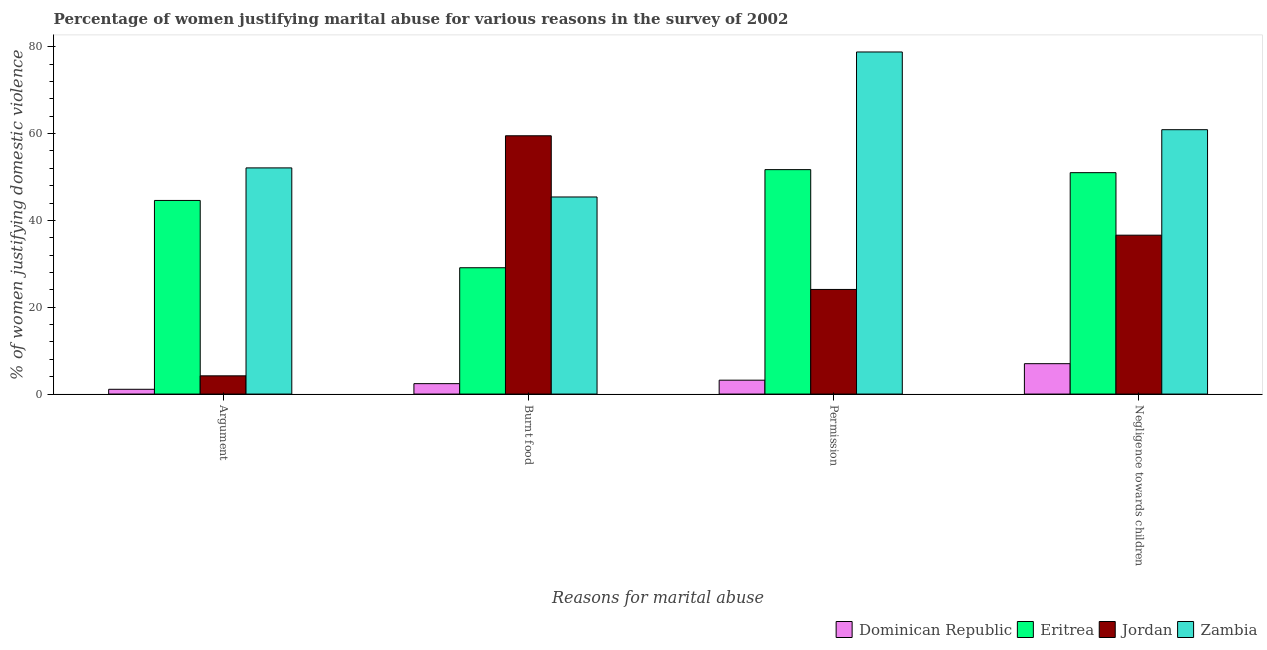Are the number of bars per tick equal to the number of legend labels?
Your response must be concise. Yes. How many bars are there on the 3rd tick from the left?
Keep it short and to the point. 4. How many bars are there on the 3rd tick from the right?
Your response must be concise. 4. What is the label of the 1st group of bars from the left?
Provide a succinct answer. Argument. What is the percentage of women justifying abuse in the case of an argument in Zambia?
Offer a terse response. 52.1. Across all countries, what is the maximum percentage of women justifying abuse for going without permission?
Ensure brevity in your answer.  78.8. In which country was the percentage of women justifying abuse for going without permission maximum?
Make the answer very short. Zambia. In which country was the percentage of women justifying abuse in the case of an argument minimum?
Ensure brevity in your answer.  Dominican Republic. What is the total percentage of women justifying abuse for going without permission in the graph?
Offer a very short reply. 157.8. What is the difference between the percentage of women justifying abuse in the case of an argument in Eritrea and that in Zambia?
Give a very brief answer. -7.5. What is the difference between the percentage of women justifying abuse for going without permission in Eritrea and the percentage of women justifying abuse in the case of an argument in Dominican Republic?
Make the answer very short. 50.6. What is the average percentage of women justifying abuse for going without permission per country?
Your answer should be compact. 39.45. What is the difference between the percentage of women justifying abuse for going without permission and percentage of women justifying abuse in the case of an argument in Eritrea?
Offer a very short reply. 7.1. What is the ratio of the percentage of women justifying abuse in the case of an argument in Zambia to that in Eritrea?
Make the answer very short. 1.17. What is the difference between the highest and the second highest percentage of women justifying abuse for going without permission?
Offer a terse response. 27.1. In how many countries, is the percentage of women justifying abuse for going without permission greater than the average percentage of women justifying abuse for going without permission taken over all countries?
Your response must be concise. 2. Is the sum of the percentage of women justifying abuse in the case of an argument in Dominican Republic and Jordan greater than the maximum percentage of women justifying abuse for showing negligence towards children across all countries?
Offer a very short reply. No. What does the 4th bar from the left in Negligence towards children represents?
Your answer should be very brief. Zambia. What does the 4th bar from the right in Burnt food represents?
Your response must be concise. Dominican Republic. Is it the case that in every country, the sum of the percentage of women justifying abuse in the case of an argument and percentage of women justifying abuse for burning food is greater than the percentage of women justifying abuse for going without permission?
Your answer should be compact. Yes. How many bars are there?
Make the answer very short. 16. Are all the bars in the graph horizontal?
Your response must be concise. No. How many countries are there in the graph?
Your answer should be compact. 4. What is the title of the graph?
Make the answer very short. Percentage of women justifying marital abuse for various reasons in the survey of 2002. Does "Estonia" appear as one of the legend labels in the graph?
Provide a succinct answer. No. What is the label or title of the X-axis?
Ensure brevity in your answer.  Reasons for marital abuse. What is the label or title of the Y-axis?
Your answer should be compact. % of women justifying domestic violence. What is the % of women justifying domestic violence in Eritrea in Argument?
Provide a short and direct response. 44.6. What is the % of women justifying domestic violence of Jordan in Argument?
Keep it short and to the point. 4.2. What is the % of women justifying domestic violence of Zambia in Argument?
Provide a short and direct response. 52.1. What is the % of women justifying domestic violence of Dominican Republic in Burnt food?
Your response must be concise. 2.4. What is the % of women justifying domestic violence in Eritrea in Burnt food?
Ensure brevity in your answer.  29.1. What is the % of women justifying domestic violence of Jordan in Burnt food?
Offer a very short reply. 59.5. What is the % of women justifying domestic violence in Zambia in Burnt food?
Your answer should be very brief. 45.4. What is the % of women justifying domestic violence in Dominican Republic in Permission?
Give a very brief answer. 3.2. What is the % of women justifying domestic violence in Eritrea in Permission?
Ensure brevity in your answer.  51.7. What is the % of women justifying domestic violence in Jordan in Permission?
Provide a short and direct response. 24.1. What is the % of women justifying domestic violence of Zambia in Permission?
Give a very brief answer. 78.8. What is the % of women justifying domestic violence of Jordan in Negligence towards children?
Your answer should be very brief. 36.6. What is the % of women justifying domestic violence in Zambia in Negligence towards children?
Provide a succinct answer. 60.9. Across all Reasons for marital abuse, what is the maximum % of women justifying domestic violence in Eritrea?
Keep it short and to the point. 51.7. Across all Reasons for marital abuse, what is the maximum % of women justifying domestic violence in Jordan?
Your answer should be very brief. 59.5. Across all Reasons for marital abuse, what is the maximum % of women justifying domestic violence in Zambia?
Keep it short and to the point. 78.8. Across all Reasons for marital abuse, what is the minimum % of women justifying domestic violence in Eritrea?
Give a very brief answer. 29.1. Across all Reasons for marital abuse, what is the minimum % of women justifying domestic violence in Jordan?
Provide a short and direct response. 4.2. Across all Reasons for marital abuse, what is the minimum % of women justifying domestic violence in Zambia?
Your response must be concise. 45.4. What is the total % of women justifying domestic violence of Dominican Republic in the graph?
Offer a terse response. 13.7. What is the total % of women justifying domestic violence in Eritrea in the graph?
Give a very brief answer. 176.4. What is the total % of women justifying domestic violence in Jordan in the graph?
Ensure brevity in your answer.  124.4. What is the total % of women justifying domestic violence of Zambia in the graph?
Provide a succinct answer. 237.2. What is the difference between the % of women justifying domestic violence of Dominican Republic in Argument and that in Burnt food?
Offer a very short reply. -1.3. What is the difference between the % of women justifying domestic violence in Eritrea in Argument and that in Burnt food?
Provide a succinct answer. 15.5. What is the difference between the % of women justifying domestic violence of Jordan in Argument and that in Burnt food?
Your response must be concise. -55.3. What is the difference between the % of women justifying domestic violence in Dominican Republic in Argument and that in Permission?
Provide a succinct answer. -2.1. What is the difference between the % of women justifying domestic violence of Eritrea in Argument and that in Permission?
Make the answer very short. -7.1. What is the difference between the % of women justifying domestic violence in Jordan in Argument and that in Permission?
Your answer should be compact. -19.9. What is the difference between the % of women justifying domestic violence of Zambia in Argument and that in Permission?
Give a very brief answer. -26.7. What is the difference between the % of women justifying domestic violence in Dominican Republic in Argument and that in Negligence towards children?
Provide a succinct answer. -5.9. What is the difference between the % of women justifying domestic violence of Jordan in Argument and that in Negligence towards children?
Offer a very short reply. -32.4. What is the difference between the % of women justifying domestic violence of Zambia in Argument and that in Negligence towards children?
Provide a succinct answer. -8.8. What is the difference between the % of women justifying domestic violence in Eritrea in Burnt food and that in Permission?
Your answer should be very brief. -22.6. What is the difference between the % of women justifying domestic violence in Jordan in Burnt food and that in Permission?
Make the answer very short. 35.4. What is the difference between the % of women justifying domestic violence in Zambia in Burnt food and that in Permission?
Your response must be concise. -33.4. What is the difference between the % of women justifying domestic violence of Eritrea in Burnt food and that in Negligence towards children?
Offer a terse response. -21.9. What is the difference between the % of women justifying domestic violence of Jordan in Burnt food and that in Negligence towards children?
Your answer should be compact. 22.9. What is the difference between the % of women justifying domestic violence in Zambia in Burnt food and that in Negligence towards children?
Keep it short and to the point. -15.5. What is the difference between the % of women justifying domestic violence in Eritrea in Permission and that in Negligence towards children?
Your answer should be very brief. 0.7. What is the difference between the % of women justifying domestic violence in Dominican Republic in Argument and the % of women justifying domestic violence in Jordan in Burnt food?
Your answer should be compact. -58.4. What is the difference between the % of women justifying domestic violence in Dominican Republic in Argument and the % of women justifying domestic violence in Zambia in Burnt food?
Give a very brief answer. -44.3. What is the difference between the % of women justifying domestic violence in Eritrea in Argument and the % of women justifying domestic violence in Jordan in Burnt food?
Your answer should be very brief. -14.9. What is the difference between the % of women justifying domestic violence in Eritrea in Argument and the % of women justifying domestic violence in Zambia in Burnt food?
Provide a succinct answer. -0.8. What is the difference between the % of women justifying domestic violence of Jordan in Argument and the % of women justifying domestic violence of Zambia in Burnt food?
Ensure brevity in your answer.  -41.2. What is the difference between the % of women justifying domestic violence in Dominican Republic in Argument and the % of women justifying domestic violence in Eritrea in Permission?
Give a very brief answer. -50.6. What is the difference between the % of women justifying domestic violence in Dominican Republic in Argument and the % of women justifying domestic violence in Zambia in Permission?
Offer a terse response. -77.7. What is the difference between the % of women justifying domestic violence in Eritrea in Argument and the % of women justifying domestic violence in Zambia in Permission?
Ensure brevity in your answer.  -34.2. What is the difference between the % of women justifying domestic violence of Jordan in Argument and the % of women justifying domestic violence of Zambia in Permission?
Give a very brief answer. -74.6. What is the difference between the % of women justifying domestic violence of Dominican Republic in Argument and the % of women justifying domestic violence of Eritrea in Negligence towards children?
Your response must be concise. -49.9. What is the difference between the % of women justifying domestic violence in Dominican Republic in Argument and the % of women justifying domestic violence in Jordan in Negligence towards children?
Offer a terse response. -35.5. What is the difference between the % of women justifying domestic violence of Dominican Republic in Argument and the % of women justifying domestic violence of Zambia in Negligence towards children?
Give a very brief answer. -59.8. What is the difference between the % of women justifying domestic violence in Eritrea in Argument and the % of women justifying domestic violence in Jordan in Negligence towards children?
Provide a short and direct response. 8. What is the difference between the % of women justifying domestic violence in Eritrea in Argument and the % of women justifying domestic violence in Zambia in Negligence towards children?
Keep it short and to the point. -16.3. What is the difference between the % of women justifying domestic violence in Jordan in Argument and the % of women justifying domestic violence in Zambia in Negligence towards children?
Keep it short and to the point. -56.7. What is the difference between the % of women justifying domestic violence of Dominican Republic in Burnt food and the % of women justifying domestic violence of Eritrea in Permission?
Make the answer very short. -49.3. What is the difference between the % of women justifying domestic violence of Dominican Republic in Burnt food and the % of women justifying domestic violence of Jordan in Permission?
Offer a very short reply. -21.7. What is the difference between the % of women justifying domestic violence of Dominican Republic in Burnt food and the % of women justifying domestic violence of Zambia in Permission?
Offer a very short reply. -76.4. What is the difference between the % of women justifying domestic violence in Eritrea in Burnt food and the % of women justifying domestic violence in Zambia in Permission?
Your response must be concise. -49.7. What is the difference between the % of women justifying domestic violence of Jordan in Burnt food and the % of women justifying domestic violence of Zambia in Permission?
Offer a very short reply. -19.3. What is the difference between the % of women justifying domestic violence in Dominican Republic in Burnt food and the % of women justifying domestic violence in Eritrea in Negligence towards children?
Provide a succinct answer. -48.6. What is the difference between the % of women justifying domestic violence of Dominican Republic in Burnt food and the % of women justifying domestic violence of Jordan in Negligence towards children?
Your answer should be very brief. -34.2. What is the difference between the % of women justifying domestic violence in Dominican Republic in Burnt food and the % of women justifying domestic violence in Zambia in Negligence towards children?
Provide a succinct answer. -58.5. What is the difference between the % of women justifying domestic violence of Eritrea in Burnt food and the % of women justifying domestic violence of Zambia in Negligence towards children?
Provide a succinct answer. -31.8. What is the difference between the % of women justifying domestic violence of Dominican Republic in Permission and the % of women justifying domestic violence of Eritrea in Negligence towards children?
Keep it short and to the point. -47.8. What is the difference between the % of women justifying domestic violence of Dominican Republic in Permission and the % of women justifying domestic violence of Jordan in Negligence towards children?
Provide a short and direct response. -33.4. What is the difference between the % of women justifying domestic violence of Dominican Republic in Permission and the % of women justifying domestic violence of Zambia in Negligence towards children?
Provide a short and direct response. -57.7. What is the difference between the % of women justifying domestic violence of Eritrea in Permission and the % of women justifying domestic violence of Jordan in Negligence towards children?
Your answer should be very brief. 15.1. What is the difference between the % of women justifying domestic violence of Eritrea in Permission and the % of women justifying domestic violence of Zambia in Negligence towards children?
Make the answer very short. -9.2. What is the difference between the % of women justifying domestic violence of Jordan in Permission and the % of women justifying domestic violence of Zambia in Negligence towards children?
Keep it short and to the point. -36.8. What is the average % of women justifying domestic violence in Dominican Republic per Reasons for marital abuse?
Give a very brief answer. 3.42. What is the average % of women justifying domestic violence of Eritrea per Reasons for marital abuse?
Your answer should be compact. 44.1. What is the average % of women justifying domestic violence of Jordan per Reasons for marital abuse?
Keep it short and to the point. 31.1. What is the average % of women justifying domestic violence of Zambia per Reasons for marital abuse?
Give a very brief answer. 59.3. What is the difference between the % of women justifying domestic violence of Dominican Republic and % of women justifying domestic violence of Eritrea in Argument?
Your response must be concise. -43.5. What is the difference between the % of women justifying domestic violence of Dominican Republic and % of women justifying domestic violence of Zambia in Argument?
Keep it short and to the point. -51. What is the difference between the % of women justifying domestic violence of Eritrea and % of women justifying domestic violence of Jordan in Argument?
Your answer should be very brief. 40.4. What is the difference between the % of women justifying domestic violence of Jordan and % of women justifying domestic violence of Zambia in Argument?
Provide a succinct answer. -47.9. What is the difference between the % of women justifying domestic violence in Dominican Republic and % of women justifying domestic violence in Eritrea in Burnt food?
Provide a succinct answer. -26.7. What is the difference between the % of women justifying domestic violence in Dominican Republic and % of women justifying domestic violence in Jordan in Burnt food?
Your answer should be compact. -57.1. What is the difference between the % of women justifying domestic violence of Dominican Republic and % of women justifying domestic violence of Zambia in Burnt food?
Provide a short and direct response. -43. What is the difference between the % of women justifying domestic violence in Eritrea and % of women justifying domestic violence in Jordan in Burnt food?
Your answer should be compact. -30.4. What is the difference between the % of women justifying domestic violence in Eritrea and % of women justifying domestic violence in Zambia in Burnt food?
Keep it short and to the point. -16.3. What is the difference between the % of women justifying domestic violence in Dominican Republic and % of women justifying domestic violence in Eritrea in Permission?
Give a very brief answer. -48.5. What is the difference between the % of women justifying domestic violence of Dominican Republic and % of women justifying domestic violence of Jordan in Permission?
Ensure brevity in your answer.  -20.9. What is the difference between the % of women justifying domestic violence of Dominican Republic and % of women justifying domestic violence of Zambia in Permission?
Provide a short and direct response. -75.6. What is the difference between the % of women justifying domestic violence in Eritrea and % of women justifying domestic violence in Jordan in Permission?
Ensure brevity in your answer.  27.6. What is the difference between the % of women justifying domestic violence of Eritrea and % of women justifying domestic violence of Zambia in Permission?
Give a very brief answer. -27.1. What is the difference between the % of women justifying domestic violence in Jordan and % of women justifying domestic violence in Zambia in Permission?
Keep it short and to the point. -54.7. What is the difference between the % of women justifying domestic violence of Dominican Republic and % of women justifying domestic violence of Eritrea in Negligence towards children?
Your response must be concise. -44. What is the difference between the % of women justifying domestic violence in Dominican Republic and % of women justifying domestic violence in Jordan in Negligence towards children?
Give a very brief answer. -29.6. What is the difference between the % of women justifying domestic violence of Dominican Republic and % of women justifying domestic violence of Zambia in Negligence towards children?
Offer a terse response. -53.9. What is the difference between the % of women justifying domestic violence of Jordan and % of women justifying domestic violence of Zambia in Negligence towards children?
Your response must be concise. -24.3. What is the ratio of the % of women justifying domestic violence of Dominican Republic in Argument to that in Burnt food?
Your response must be concise. 0.46. What is the ratio of the % of women justifying domestic violence of Eritrea in Argument to that in Burnt food?
Offer a terse response. 1.53. What is the ratio of the % of women justifying domestic violence of Jordan in Argument to that in Burnt food?
Provide a short and direct response. 0.07. What is the ratio of the % of women justifying domestic violence in Zambia in Argument to that in Burnt food?
Keep it short and to the point. 1.15. What is the ratio of the % of women justifying domestic violence in Dominican Republic in Argument to that in Permission?
Offer a terse response. 0.34. What is the ratio of the % of women justifying domestic violence of Eritrea in Argument to that in Permission?
Your answer should be compact. 0.86. What is the ratio of the % of women justifying domestic violence in Jordan in Argument to that in Permission?
Provide a succinct answer. 0.17. What is the ratio of the % of women justifying domestic violence in Zambia in Argument to that in Permission?
Your answer should be very brief. 0.66. What is the ratio of the % of women justifying domestic violence of Dominican Republic in Argument to that in Negligence towards children?
Provide a short and direct response. 0.16. What is the ratio of the % of women justifying domestic violence of Eritrea in Argument to that in Negligence towards children?
Keep it short and to the point. 0.87. What is the ratio of the % of women justifying domestic violence of Jordan in Argument to that in Negligence towards children?
Keep it short and to the point. 0.11. What is the ratio of the % of women justifying domestic violence of Zambia in Argument to that in Negligence towards children?
Your response must be concise. 0.86. What is the ratio of the % of women justifying domestic violence in Dominican Republic in Burnt food to that in Permission?
Give a very brief answer. 0.75. What is the ratio of the % of women justifying domestic violence of Eritrea in Burnt food to that in Permission?
Provide a succinct answer. 0.56. What is the ratio of the % of women justifying domestic violence of Jordan in Burnt food to that in Permission?
Provide a succinct answer. 2.47. What is the ratio of the % of women justifying domestic violence of Zambia in Burnt food to that in Permission?
Your answer should be very brief. 0.58. What is the ratio of the % of women justifying domestic violence of Dominican Republic in Burnt food to that in Negligence towards children?
Offer a very short reply. 0.34. What is the ratio of the % of women justifying domestic violence in Eritrea in Burnt food to that in Negligence towards children?
Make the answer very short. 0.57. What is the ratio of the % of women justifying domestic violence in Jordan in Burnt food to that in Negligence towards children?
Ensure brevity in your answer.  1.63. What is the ratio of the % of women justifying domestic violence of Zambia in Burnt food to that in Negligence towards children?
Your answer should be compact. 0.75. What is the ratio of the % of women justifying domestic violence of Dominican Republic in Permission to that in Negligence towards children?
Your response must be concise. 0.46. What is the ratio of the % of women justifying domestic violence in Eritrea in Permission to that in Negligence towards children?
Your response must be concise. 1.01. What is the ratio of the % of women justifying domestic violence of Jordan in Permission to that in Negligence towards children?
Provide a succinct answer. 0.66. What is the ratio of the % of women justifying domestic violence of Zambia in Permission to that in Negligence towards children?
Ensure brevity in your answer.  1.29. What is the difference between the highest and the second highest % of women justifying domestic violence of Jordan?
Ensure brevity in your answer.  22.9. What is the difference between the highest and the lowest % of women justifying domestic violence of Eritrea?
Make the answer very short. 22.6. What is the difference between the highest and the lowest % of women justifying domestic violence of Jordan?
Your response must be concise. 55.3. What is the difference between the highest and the lowest % of women justifying domestic violence in Zambia?
Offer a very short reply. 33.4. 